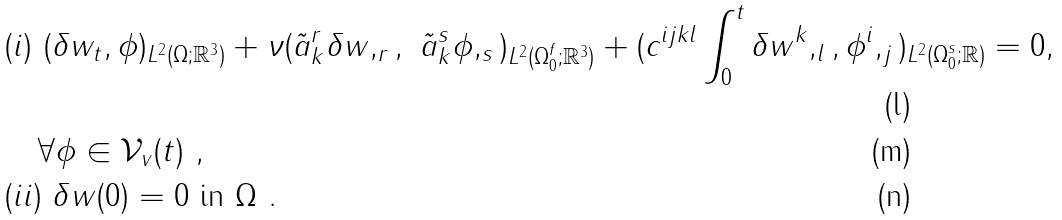<formula> <loc_0><loc_0><loc_500><loc_500>& ( i ) \ ( \delta w _ { t } , \phi ) _ { L ^ { 2 } ( \Omega ; { \mathbb { R } } ^ { 3 } ) } + { \nu } ( \tilde { a } _ { k } ^ { r } \delta w , _ { r } , \ \tilde { a } _ { k } ^ { s } \phi , _ { s } ) _ { L ^ { 2 } ( \Omega _ { 0 } ^ { f } ; { \mathbb { R } } ^ { 3 } ) } + ( c ^ { i j k l } \int _ { 0 } ^ { t } \delta w ^ { k } , _ { l } , \phi ^ { i } , _ { j } ) _ { L ^ { 2 } ( \Omega _ { 0 } ^ { s } ; { \mathbb { R } } ) } = 0 , \\ & \quad \forall \phi \in { \mathcal { V } } _ { v } ( t ) \ , \\ & ( i i ) \ \delta w ( 0 ) = 0 \ \text {in} \ \Omega \ .</formula> 